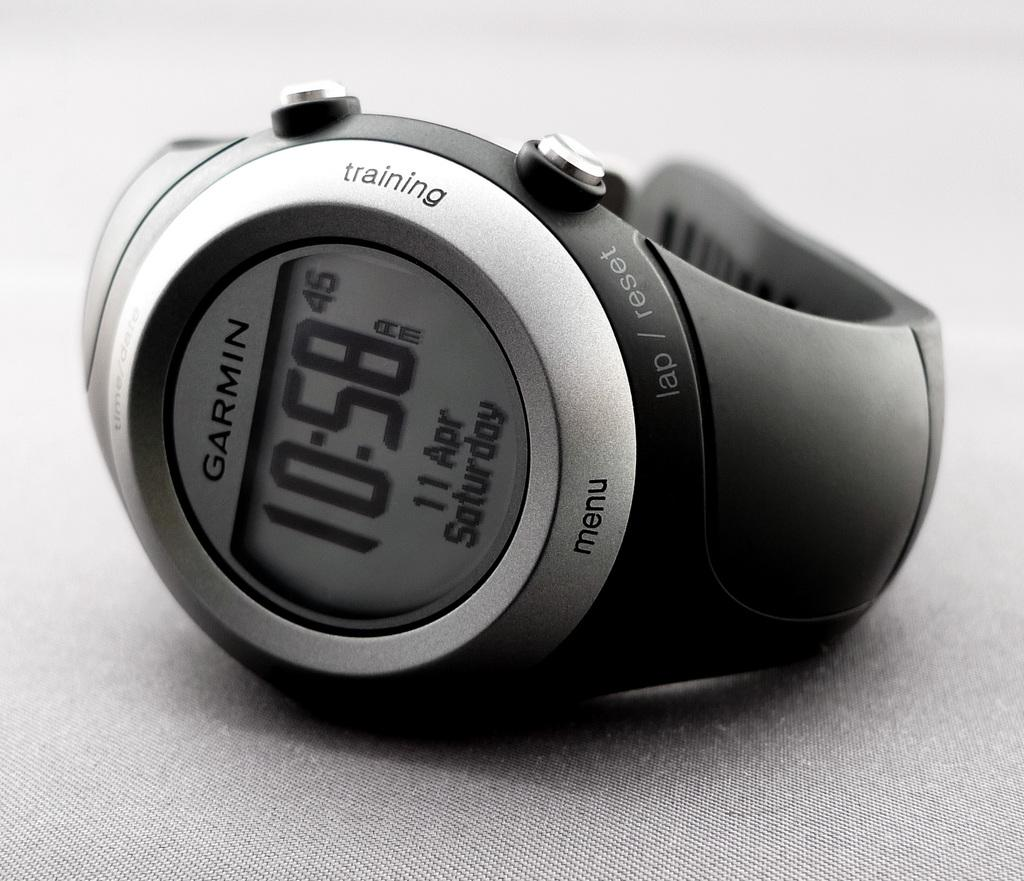<image>
Present a compact description of the photo's key features. black watch with the time 10:58 fir the time 